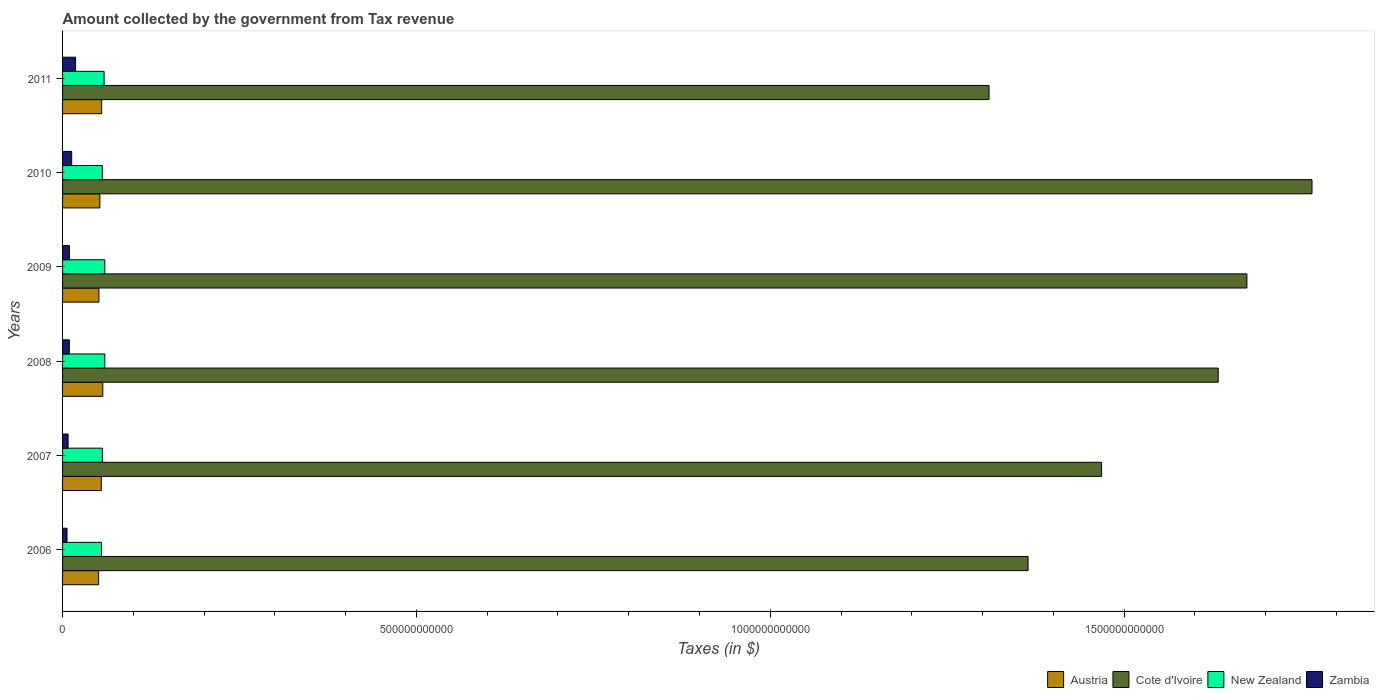How many different coloured bars are there?
Give a very brief answer. 4. Are the number of bars on each tick of the Y-axis equal?
Give a very brief answer. Yes. How many bars are there on the 3rd tick from the bottom?
Offer a very short reply. 4. In how many cases, is the number of bars for a given year not equal to the number of legend labels?
Provide a succinct answer. 0. What is the amount collected by the government from tax revenue in Cote d'Ivoire in 2009?
Your answer should be very brief. 1.67e+12. Across all years, what is the maximum amount collected by the government from tax revenue in Zambia?
Offer a terse response. 1.84e+1. Across all years, what is the minimum amount collected by the government from tax revenue in Cote d'Ivoire?
Offer a terse response. 1.31e+12. What is the total amount collected by the government from tax revenue in Zambia in the graph?
Provide a short and direct response. 6.46e+1. What is the difference between the amount collected by the government from tax revenue in Cote d'Ivoire in 2009 and that in 2010?
Keep it short and to the point. -9.20e+1. What is the difference between the amount collected by the government from tax revenue in Zambia in 2010 and the amount collected by the government from tax revenue in New Zealand in 2009?
Keep it short and to the point. -4.68e+1. What is the average amount collected by the government from tax revenue in Cote d'Ivoire per year?
Your response must be concise. 1.54e+12. In the year 2008, what is the difference between the amount collected by the government from tax revenue in Cote d'Ivoire and amount collected by the government from tax revenue in Zambia?
Ensure brevity in your answer.  1.62e+12. In how many years, is the amount collected by the government from tax revenue in Cote d'Ivoire greater than 100000000000 $?
Provide a short and direct response. 6. What is the ratio of the amount collected by the government from tax revenue in Cote d'Ivoire in 2010 to that in 2011?
Your answer should be compact. 1.35. What is the difference between the highest and the second highest amount collected by the government from tax revenue in New Zealand?
Offer a terse response. 6.41e+07. What is the difference between the highest and the lowest amount collected by the government from tax revenue in New Zealand?
Your answer should be compact. 4.69e+09. In how many years, is the amount collected by the government from tax revenue in Cote d'Ivoire greater than the average amount collected by the government from tax revenue in Cote d'Ivoire taken over all years?
Your answer should be very brief. 3. What does the 2nd bar from the top in 2006 represents?
Your answer should be very brief. New Zealand. What does the 4th bar from the bottom in 2011 represents?
Ensure brevity in your answer.  Zambia. Is it the case that in every year, the sum of the amount collected by the government from tax revenue in Cote d'Ivoire and amount collected by the government from tax revenue in New Zealand is greater than the amount collected by the government from tax revenue in Zambia?
Give a very brief answer. Yes. How many bars are there?
Provide a succinct answer. 24. Are all the bars in the graph horizontal?
Offer a very short reply. Yes. How many years are there in the graph?
Give a very brief answer. 6. What is the difference between two consecutive major ticks on the X-axis?
Make the answer very short. 5.00e+11. How are the legend labels stacked?
Your answer should be compact. Horizontal. What is the title of the graph?
Provide a succinct answer. Amount collected by the government from Tax revenue. What is the label or title of the X-axis?
Make the answer very short. Taxes (in $). What is the label or title of the Y-axis?
Your answer should be compact. Years. What is the Taxes (in $) of Austria in 2006?
Provide a succinct answer. 5.10e+1. What is the Taxes (in $) of Cote d'Ivoire in 2006?
Provide a short and direct response. 1.36e+12. What is the Taxes (in $) in New Zealand in 2006?
Provide a succinct answer. 5.50e+1. What is the Taxes (in $) in Zambia in 2006?
Make the answer very short. 6.30e+09. What is the Taxes (in $) of Austria in 2007?
Make the answer very short. 5.47e+1. What is the Taxes (in $) of Cote d'Ivoire in 2007?
Offer a terse response. 1.47e+12. What is the Taxes (in $) in New Zealand in 2007?
Give a very brief answer. 5.62e+1. What is the Taxes (in $) of Zambia in 2007?
Provide a succinct answer. 7.80e+09. What is the Taxes (in $) in Austria in 2008?
Your answer should be very brief. 5.69e+1. What is the Taxes (in $) in Cote d'Ivoire in 2008?
Ensure brevity in your answer.  1.63e+12. What is the Taxes (in $) in New Zealand in 2008?
Make the answer very short. 5.97e+1. What is the Taxes (in $) of Zambia in 2008?
Provide a succinct answer. 9.54e+09. What is the Taxes (in $) of Austria in 2009?
Keep it short and to the point. 5.14e+1. What is the Taxes (in $) in Cote d'Ivoire in 2009?
Give a very brief answer. 1.67e+12. What is the Taxes (in $) of New Zealand in 2009?
Offer a terse response. 5.96e+1. What is the Taxes (in $) in Zambia in 2009?
Your answer should be compact. 9.67e+09. What is the Taxes (in $) in Austria in 2010?
Provide a succinct answer. 5.27e+1. What is the Taxes (in $) of Cote d'Ivoire in 2010?
Your answer should be very brief. 1.77e+12. What is the Taxes (in $) in New Zealand in 2010?
Your response must be concise. 5.61e+1. What is the Taxes (in $) in Zambia in 2010?
Your response must be concise. 1.29e+1. What is the Taxes (in $) of Austria in 2011?
Your response must be concise. 5.52e+1. What is the Taxes (in $) of Cote d'Ivoire in 2011?
Provide a succinct answer. 1.31e+12. What is the Taxes (in $) of New Zealand in 2011?
Your answer should be very brief. 5.87e+1. What is the Taxes (in $) in Zambia in 2011?
Ensure brevity in your answer.  1.84e+1. Across all years, what is the maximum Taxes (in $) in Austria?
Ensure brevity in your answer.  5.69e+1. Across all years, what is the maximum Taxes (in $) in Cote d'Ivoire?
Provide a succinct answer. 1.77e+12. Across all years, what is the maximum Taxes (in $) of New Zealand?
Provide a succinct answer. 5.97e+1. Across all years, what is the maximum Taxes (in $) in Zambia?
Provide a succinct answer. 1.84e+1. Across all years, what is the minimum Taxes (in $) in Austria?
Keep it short and to the point. 5.10e+1. Across all years, what is the minimum Taxes (in $) of Cote d'Ivoire?
Ensure brevity in your answer.  1.31e+12. Across all years, what is the minimum Taxes (in $) in New Zealand?
Your answer should be very brief. 5.50e+1. Across all years, what is the minimum Taxes (in $) in Zambia?
Keep it short and to the point. 6.30e+09. What is the total Taxes (in $) in Austria in the graph?
Give a very brief answer. 3.22e+11. What is the total Taxes (in $) of Cote d'Ivoire in the graph?
Keep it short and to the point. 9.21e+12. What is the total Taxes (in $) of New Zealand in the graph?
Offer a terse response. 3.45e+11. What is the total Taxes (in $) of Zambia in the graph?
Give a very brief answer. 6.46e+1. What is the difference between the Taxes (in $) in Austria in 2006 and that in 2007?
Offer a very short reply. -3.76e+09. What is the difference between the Taxes (in $) in Cote d'Ivoire in 2006 and that in 2007?
Provide a succinct answer. -1.04e+11. What is the difference between the Taxes (in $) of New Zealand in 2006 and that in 2007?
Your answer should be very brief. -1.19e+09. What is the difference between the Taxes (in $) in Zambia in 2006 and that in 2007?
Provide a succinct answer. -1.50e+09. What is the difference between the Taxes (in $) in Austria in 2006 and that in 2008?
Provide a succinct answer. -5.88e+09. What is the difference between the Taxes (in $) of Cote d'Ivoire in 2006 and that in 2008?
Your response must be concise. -2.69e+11. What is the difference between the Taxes (in $) of New Zealand in 2006 and that in 2008?
Offer a very short reply. -4.69e+09. What is the difference between the Taxes (in $) in Zambia in 2006 and that in 2008?
Provide a succinct answer. -3.24e+09. What is the difference between the Taxes (in $) of Austria in 2006 and that in 2009?
Keep it short and to the point. -3.78e+08. What is the difference between the Taxes (in $) of Cote d'Ivoire in 2006 and that in 2009?
Your answer should be compact. -3.09e+11. What is the difference between the Taxes (in $) in New Zealand in 2006 and that in 2009?
Your answer should be compact. -4.63e+09. What is the difference between the Taxes (in $) in Zambia in 2006 and that in 2009?
Your answer should be very brief. -3.37e+09. What is the difference between the Taxes (in $) in Austria in 2006 and that in 2010?
Give a very brief answer. -1.77e+09. What is the difference between the Taxes (in $) of Cote d'Ivoire in 2006 and that in 2010?
Offer a very short reply. -4.01e+11. What is the difference between the Taxes (in $) of New Zealand in 2006 and that in 2010?
Offer a very short reply. -1.13e+09. What is the difference between the Taxes (in $) of Zambia in 2006 and that in 2010?
Offer a terse response. -6.58e+09. What is the difference between the Taxes (in $) of Austria in 2006 and that in 2011?
Your answer should be compact. -4.25e+09. What is the difference between the Taxes (in $) in Cote d'Ivoire in 2006 and that in 2011?
Make the answer very short. 5.51e+1. What is the difference between the Taxes (in $) of New Zealand in 2006 and that in 2011?
Keep it short and to the point. -3.67e+09. What is the difference between the Taxes (in $) in Zambia in 2006 and that in 2011?
Your response must be concise. -1.21e+1. What is the difference between the Taxes (in $) of Austria in 2007 and that in 2008?
Make the answer very short. -2.12e+09. What is the difference between the Taxes (in $) of Cote d'Ivoire in 2007 and that in 2008?
Ensure brevity in your answer.  -1.65e+11. What is the difference between the Taxes (in $) of New Zealand in 2007 and that in 2008?
Your answer should be very brief. -3.50e+09. What is the difference between the Taxes (in $) of Zambia in 2007 and that in 2008?
Your response must be concise. -1.74e+09. What is the difference between the Taxes (in $) of Austria in 2007 and that in 2009?
Keep it short and to the point. 3.38e+09. What is the difference between the Taxes (in $) in Cote d'Ivoire in 2007 and that in 2009?
Your answer should be very brief. -2.05e+11. What is the difference between the Taxes (in $) of New Zealand in 2007 and that in 2009?
Make the answer very short. -3.44e+09. What is the difference between the Taxes (in $) of Zambia in 2007 and that in 2009?
Your answer should be compact. -1.87e+09. What is the difference between the Taxes (in $) in Austria in 2007 and that in 2010?
Give a very brief answer. 1.99e+09. What is the difference between the Taxes (in $) in Cote d'Ivoire in 2007 and that in 2010?
Provide a short and direct response. -2.97e+11. What is the difference between the Taxes (in $) of New Zealand in 2007 and that in 2010?
Offer a terse response. 5.94e+07. What is the difference between the Taxes (in $) of Zambia in 2007 and that in 2010?
Offer a terse response. -5.08e+09. What is the difference between the Taxes (in $) of Austria in 2007 and that in 2011?
Give a very brief answer. -4.92e+08. What is the difference between the Taxes (in $) of Cote d'Ivoire in 2007 and that in 2011?
Offer a very short reply. 1.59e+11. What is the difference between the Taxes (in $) of New Zealand in 2007 and that in 2011?
Provide a short and direct response. -2.48e+09. What is the difference between the Taxes (in $) of Zambia in 2007 and that in 2011?
Offer a very short reply. -1.06e+1. What is the difference between the Taxes (in $) in Austria in 2008 and that in 2009?
Offer a terse response. 5.50e+09. What is the difference between the Taxes (in $) of Cote d'Ivoire in 2008 and that in 2009?
Keep it short and to the point. -4.06e+1. What is the difference between the Taxes (in $) of New Zealand in 2008 and that in 2009?
Give a very brief answer. 6.41e+07. What is the difference between the Taxes (in $) of Zambia in 2008 and that in 2009?
Your answer should be compact. -1.29e+08. What is the difference between the Taxes (in $) of Austria in 2008 and that in 2010?
Your response must be concise. 4.11e+09. What is the difference between the Taxes (in $) of Cote d'Ivoire in 2008 and that in 2010?
Offer a terse response. -1.33e+11. What is the difference between the Taxes (in $) of New Zealand in 2008 and that in 2010?
Keep it short and to the point. 3.56e+09. What is the difference between the Taxes (in $) in Zambia in 2008 and that in 2010?
Your answer should be compact. -3.34e+09. What is the difference between the Taxes (in $) in Austria in 2008 and that in 2011?
Your response must be concise. 1.62e+09. What is the difference between the Taxes (in $) in Cote d'Ivoire in 2008 and that in 2011?
Your response must be concise. 3.24e+11. What is the difference between the Taxes (in $) in New Zealand in 2008 and that in 2011?
Offer a terse response. 1.03e+09. What is the difference between the Taxes (in $) of Zambia in 2008 and that in 2011?
Your answer should be compact. -8.87e+09. What is the difference between the Taxes (in $) in Austria in 2009 and that in 2010?
Provide a short and direct response. -1.39e+09. What is the difference between the Taxes (in $) in Cote d'Ivoire in 2009 and that in 2010?
Your response must be concise. -9.20e+1. What is the difference between the Taxes (in $) in New Zealand in 2009 and that in 2010?
Make the answer very short. 3.50e+09. What is the difference between the Taxes (in $) of Zambia in 2009 and that in 2010?
Your answer should be very brief. -3.21e+09. What is the difference between the Taxes (in $) in Austria in 2009 and that in 2011?
Offer a terse response. -3.88e+09. What is the difference between the Taxes (in $) in Cote d'Ivoire in 2009 and that in 2011?
Keep it short and to the point. 3.64e+11. What is the difference between the Taxes (in $) in New Zealand in 2009 and that in 2011?
Keep it short and to the point. 9.61e+08. What is the difference between the Taxes (in $) of Zambia in 2009 and that in 2011?
Your answer should be compact. -8.75e+09. What is the difference between the Taxes (in $) in Austria in 2010 and that in 2011?
Your answer should be compact. -2.49e+09. What is the difference between the Taxes (in $) of Cote d'Ivoire in 2010 and that in 2011?
Give a very brief answer. 4.56e+11. What is the difference between the Taxes (in $) of New Zealand in 2010 and that in 2011?
Make the answer very short. -2.54e+09. What is the difference between the Taxes (in $) of Zambia in 2010 and that in 2011?
Offer a terse response. -5.54e+09. What is the difference between the Taxes (in $) of Austria in 2006 and the Taxes (in $) of Cote d'Ivoire in 2007?
Provide a short and direct response. -1.42e+12. What is the difference between the Taxes (in $) of Austria in 2006 and the Taxes (in $) of New Zealand in 2007?
Offer a terse response. -5.23e+09. What is the difference between the Taxes (in $) in Austria in 2006 and the Taxes (in $) in Zambia in 2007?
Keep it short and to the point. 4.32e+1. What is the difference between the Taxes (in $) of Cote d'Ivoire in 2006 and the Taxes (in $) of New Zealand in 2007?
Make the answer very short. 1.31e+12. What is the difference between the Taxes (in $) in Cote d'Ivoire in 2006 and the Taxes (in $) in Zambia in 2007?
Provide a succinct answer. 1.36e+12. What is the difference between the Taxes (in $) of New Zealand in 2006 and the Taxes (in $) of Zambia in 2007?
Provide a short and direct response. 4.72e+1. What is the difference between the Taxes (in $) in Austria in 2006 and the Taxes (in $) in Cote d'Ivoire in 2008?
Make the answer very short. -1.58e+12. What is the difference between the Taxes (in $) of Austria in 2006 and the Taxes (in $) of New Zealand in 2008?
Offer a very short reply. -8.73e+09. What is the difference between the Taxes (in $) in Austria in 2006 and the Taxes (in $) in Zambia in 2008?
Your answer should be very brief. 4.14e+1. What is the difference between the Taxes (in $) of Cote d'Ivoire in 2006 and the Taxes (in $) of New Zealand in 2008?
Your answer should be very brief. 1.30e+12. What is the difference between the Taxes (in $) in Cote d'Ivoire in 2006 and the Taxes (in $) in Zambia in 2008?
Provide a short and direct response. 1.35e+12. What is the difference between the Taxes (in $) of New Zealand in 2006 and the Taxes (in $) of Zambia in 2008?
Offer a very short reply. 4.55e+1. What is the difference between the Taxes (in $) in Austria in 2006 and the Taxes (in $) in Cote d'Ivoire in 2009?
Your answer should be compact. -1.62e+12. What is the difference between the Taxes (in $) of Austria in 2006 and the Taxes (in $) of New Zealand in 2009?
Make the answer very short. -8.67e+09. What is the difference between the Taxes (in $) in Austria in 2006 and the Taxes (in $) in Zambia in 2009?
Your response must be concise. 4.13e+1. What is the difference between the Taxes (in $) in Cote d'Ivoire in 2006 and the Taxes (in $) in New Zealand in 2009?
Offer a very short reply. 1.30e+12. What is the difference between the Taxes (in $) in Cote d'Ivoire in 2006 and the Taxes (in $) in Zambia in 2009?
Your answer should be very brief. 1.35e+12. What is the difference between the Taxes (in $) in New Zealand in 2006 and the Taxes (in $) in Zambia in 2009?
Offer a very short reply. 4.53e+1. What is the difference between the Taxes (in $) of Austria in 2006 and the Taxes (in $) of Cote d'Ivoire in 2010?
Provide a succinct answer. -1.71e+12. What is the difference between the Taxes (in $) in Austria in 2006 and the Taxes (in $) in New Zealand in 2010?
Your answer should be very brief. -5.17e+09. What is the difference between the Taxes (in $) of Austria in 2006 and the Taxes (in $) of Zambia in 2010?
Keep it short and to the point. 3.81e+1. What is the difference between the Taxes (in $) of Cote d'Ivoire in 2006 and the Taxes (in $) of New Zealand in 2010?
Your answer should be very brief. 1.31e+12. What is the difference between the Taxes (in $) of Cote d'Ivoire in 2006 and the Taxes (in $) of Zambia in 2010?
Offer a very short reply. 1.35e+12. What is the difference between the Taxes (in $) in New Zealand in 2006 and the Taxes (in $) in Zambia in 2010?
Ensure brevity in your answer.  4.21e+1. What is the difference between the Taxes (in $) of Austria in 2006 and the Taxes (in $) of Cote d'Ivoire in 2011?
Provide a short and direct response. -1.26e+12. What is the difference between the Taxes (in $) of Austria in 2006 and the Taxes (in $) of New Zealand in 2011?
Your response must be concise. -7.71e+09. What is the difference between the Taxes (in $) in Austria in 2006 and the Taxes (in $) in Zambia in 2011?
Offer a terse response. 3.26e+1. What is the difference between the Taxes (in $) in Cote d'Ivoire in 2006 and the Taxes (in $) in New Zealand in 2011?
Give a very brief answer. 1.31e+12. What is the difference between the Taxes (in $) in Cote d'Ivoire in 2006 and the Taxes (in $) in Zambia in 2011?
Offer a terse response. 1.35e+12. What is the difference between the Taxes (in $) of New Zealand in 2006 and the Taxes (in $) of Zambia in 2011?
Your response must be concise. 3.66e+1. What is the difference between the Taxes (in $) of Austria in 2007 and the Taxes (in $) of Cote d'Ivoire in 2008?
Give a very brief answer. -1.58e+12. What is the difference between the Taxes (in $) in Austria in 2007 and the Taxes (in $) in New Zealand in 2008?
Ensure brevity in your answer.  -4.97e+09. What is the difference between the Taxes (in $) of Austria in 2007 and the Taxes (in $) of Zambia in 2008?
Your answer should be compact. 4.52e+1. What is the difference between the Taxes (in $) of Cote d'Ivoire in 2007 and the Taxes (in $) of New Zealand in 2008?
Provide a succinct answer. 1.41e+12. What is the difference between the Taxes (in $) in Cote d'Ivoire in 2007 and the Taxes (in $) in Zambia in 2008?
Ensure brevity in your answer.  1.46e+12. What is the difference between the Taxes (in $) in New Zealand in 2007 and the Taxes (in $) in Zambia in 2008?
Give a very brief answer. 4.67e+1. What is the difference between the Taxes (in $) of Austria in 2007 and the Taxes (in $) of Cote d'Ivoire in 2009?
Give a very brief answer. -1.62e+12. What is the difference between the Taxes (in $) in Austria in 2007 and the Taxes (in $) in New Zealand in 2009?
Ensure brevity in your answer.  -4.91e+09. What is the difference between the Taxes (in $) of Austria in 2007 and the Taxes (in $) of Zambia in 2009?
Offer a very short reply. 4.51e+1. What is the difference between the Taxes (in $) of Cote d'Ivoire in 2007 and the Taxes (in $) of New Zealand in 2009?
Your answer should be very brief. 1.41e+12. What is the difference between the Taxes (in $) in Cote d'Ivoire in 2007 and the Taxes (in $) in Zambia in 2009?
Ensure brevity in your answer.  1.46e+12. What is the difference between the Taxes (in $) in New Zealand in 2007 and the Taxes (in $) in Zambia in 2009?
Ensure brevity in your answer.  4.65e+1. What is the difference between the Taxes (in $) in Austria in 2007 and the Taxes (in $) in Cote d'Ivoire in 2010?
Offer a terse response. -1.71e+12. What is the difference between the Taxes (in $) in Austria in 2007 and the Taxes (in $) in New Zealand in 2010?
Provide a succinct answer. -1.41e+09. What is the difference between the Taxes (in $) of Austria in 2007 and the Taxes (in $) of Zambia in 2010?
Keep it short and to the point. 4.19e+1. What is the difference between the Taxes (in $) of Cote d'Ivoire in 2007 and the Taxes (in $) of New Zealand in 2010?
Provide a short and direct response. 1.41e+12. What is the difference between the Taxes (in $) in Cote d'Ivoire in 2007 and the Taxes (in $) in Zambia in 2010?
Offer a terse response. 1.46e+12. What is the difference between the Taxes (in $) of New Zealand in 2007 and the Taxes (in $) of Zambia in 2010?
Offer a very short reply. 4.33e+1. What is the difference between the Taxes (in $) of Austria in 2007 and the Taxes (in $) of Cote d'Ivoire in 2011?
Provide a succinct answer. -1.25e+12. What is the difference between the Taxes (in $) in Austria in 2007 and the Taxes (in $) in New Zealand in 2011?
Offer a terse response. -3.95e+09. What is the difference between the Taxes (in $) in Austria in 2007 and the Taxes (in $) in Zambia in 2011?
Ensure brevity in your answer.  3.63e+1. What is the difference between the Taxes (in $) in Cote d'Ivoire in 2007 and the Taxes (in $) in New Zealand in 2011?
Offer a terse response. 1.41e+12. What is the difference between the Taxes (in $) in Cote d'Ivoire in 2007 and the Taxes (in $) in Zambia in 2011?
Ensure brevity in your answer.  1.45e+12. What is the difference between the Taxes (in $) of New Zealand in 2007 and the Taxes (in $) of Zambia in 2011?
Offer a very short reply. 3.78e+1. What is the difference between the Taxes (in $) of Austria in 2008 and the Taxes (in $) of Cote d'Ivoire in 2009?
Make the answer very short. -1.62e+12. What is the difference between the Taxes (in $) in Austria in 2008 and the Taxes (in $) in New Zealand in 2009?
Your response must be concise. -2.79e+09. What is the difference between the Taxes (in $) in Austria in 2008 and the Taxes (in $) in Zambia in 2009?
Your answer should be compact. 4.72e+1. What is the difference between the Taxes (in $) in Cote d'Ivoire in 2008 and the Taxes (in $) in New Zealand in 2009?
Offer a terse response. 1.57e+12. What is the difference between the Taxes (in $) of Cote d'Ivoire in 2008 and the Taxes (in $) of Zambia in 2009?
Ensure brevity in your answer.  1.62e+12. What is the difference between the Taxes (in $) in New Zealand in 2008 and the Taxes (in $) in Zambia in 2009?
Provide a short and direct response. 5.00e+1. What is the difference between the Taxes (in $) of Austria in 2008 and the Taxes (in $) of Cote d'Ivoire in 2010?
Give a very brief answer. -1.71e+12. What is the difference between the Taxes (in $) in Austria in 2008 and the Taxes (in $) in New Zealand in 2010?
Provide a succinct answer. 7.08e+08. What is the difference between the Taxes (in $) in Austria in 2008 and the Taxes (in $) in Zambia in 2010?
Keep it short and to the point. 4.40e+1. What is the difference between the Taxes (in $) in Cote d'Ivoire in 2008 and the Taxes (in $) in New Zealand in 2010?
Your answer should be compact. 1.58e+12. What is the difference between the Taxes (in $) in Cote d'Ivoire in 2008 and the Taxes (in $) in Zambia in 2010?
Your answer should be compact. 1.62e+12. What is the difference between the Taxes (in $) in New Zealand in 2008 and the Taxes (in $) in Zambia in 2010?
Make the answer very short. 4.68e+1. What is the difference between the Taxes (in $) of Austria in 2008 and the Taxes (in $) of Cote d'Ivoire in 2011?
Provide a succinct answer. -1.25e+12. What is the difference between the Taxes (in $) in Austria in 2008 and the Taxes (in $) in New Zealand in 2011?
Make the answer very short. -1.83e+09. What is the difference between the Taxes (in $) of Austria in 2008 and the Taxes (in $) of Zambia in 2011?
Keep it short and to the point. 3.84e+1. What is the difference between the Taxes (in $) of Cote d'Ivoire in 2008 and the Taxes (in $) of New Zealand in 2011?
Your response must be concise. 1.57e+12. What is the difference between the Taxes (in $) in Cote d'Ivoire in 2008 and the Taxes (in $) in Zambia in 2011?
Give a very brief answer. 1.61e+12. What is the difference between the Taxes (in $) of New Zealand in 2008 and the Taxes (in $) of Zambia in 2011?
Your answer should be compact. 4.13e+1. What is the difference between the Taxes (in $) in Austria in 2009 and the Taxes (in $) in Cote d'Ivoire in 2010?
Your answer should be compact. -1.71e+12. What is the difference between the Taxes (in $) in Austria in 2009 and the Taxes (in $) in New Zealand in 2010?
Your answer should be very brief. -4.79e+09. What is the difference between the Taxes (in $) of Austria in 2009 and the Taxes (in $) of Zambia in 2010?
Make the answer very short. 3.85e+1. What is the difference between the Taxes (in $) of Cote d'Ivoire in 2009 and the Taxes (in $) of New Zealand in 2010?
Give a very brief answer. 1.62e+12. What is the difference between the Taxes (in $) in Cote d'Ivoire in 2009 and the Taxes (in $) in Zambia in 2010?
Offer a very short reply. 1.66e+12. What is the difference between the Taxes (in $) of New Zealand in 2009 and the Taxes (in $) of Zambia in 2010?
Your response must be concise. 4.68e+1. What is the difference between the Taxes (in $) of Austria in 2009 and the Taxes (in $) of Cote d'Ivoire in 2011?
Ensure brevity in your answer.  -1.26e+12. What is the difference between the Taxes (in $) of Austria in 2009 and the Taxes (in $) of New Zealand in 2011?
Make the answer very short. -7.33e+09. What is the difference between the Taxes (in $) of Austria in 2009 and the Taxes (in $) of Zambia in 2011?
Keep it short and to the point. 3.29e+1. What is the difference between the Taxes (in $) of Cote d'Ivoire in 2009 and the Taxes (in $) of New Zealand in 2011?
Ensure brevity in your answer.  1.61e+12. What is the difference between the Taxes (in $) in Cote d'Ivoire in 2009 and the Taxes (in $) in Zambia in 2011?
Give a very brief answer. 1.66e+12. What is the difference between the Taxes (in $) of New Zealand in 2009 and the Taxes (in $) of Zambia in 2011?
Offer a very short reply. 4.12e+1. What is the difference between the Taxes (in $) of Austria in 2010 and the Taxes (in $) of Cote d'Ivoire in 2011?
Keep it short and to the point. -1.26e+12. What is the difference between the Taxes (in $) of Austria in 2010 and the Taxes (in $) of New Zealand in 2011?
Provide a short and direct response. -5.94e+09. What is the difference between the Taxes (in $) in Austria in 2010 and the Taxes (in $) in Zambia in 2011?
Offer a very short reply. 3.43e+1. What is the difference between the Taxes (in $) in Cote d'Ivoire in 2010 and the Taxes (in $) in New Zealand in 2011?
Keep it short and to the point. 1.71e+12. What is the difference between the Taxes (in $) in Cote d'Ivoire in 2010 and the Taxes (in $) in Zambia in 2011?
Offer a very short reply. 1.75e+12. What is the difference between the Taxes (in $) in New Zealand in 2010 and the Taxes (in $) in Zambia in 2011?
Provide a succinct answer. 3.77e+1. What is the average Taxes (in $) of Austria per year?
Give a very brief answer. 5.37e+1. What is the average Taxes (in $) of Cote d'Ivoire per year?
Provide a short and direct response. 1.54e+12. What is the average Taxes (in $) in New Zealand per year?
Your answer should be very brief. 5.76e+1. What is the average Taxes (in $) in Zambia per year?
Your answer should be compact. 1.08e+1. In the year 2006, what is the difference between the Taxes (in $) of Austria and Taxes (in $) of Cote d'Ivoire?
Your answer should be very brief. -1.31e+12. In the year 2006, what is the difference between the Taxes (in $) in Austria and Taxes (in $) in New Zealand?
Provide a short and direct response. -4.04e+09. In the year 2006, what is the difference between the Taxes (in $) of Austria and Taxes (in $) of Zambia?
Your answer should be very brief. 4.47e+1. In the year 2006, what is the difference between the Taxes (in $) of Cote d'Ivoire and Taxes (in $) of New Zealand?
Provide a short and direct response. 1.31e+12. In the year 2006, what is the difference between the Taxes (in $) in Cote d'Ivoire and Taxes (in $) in Zambia?
Your answer should be very brief. 1.36e+12. In the year 2006, what is the difference between the Taxes (in $) in New Zealand and Taxes (in $) in Zambia?
Ensure brevity in your answer.  4.87e+1. In the year 2007, what is the difference between the Taxes (in $) in Austria and Taxes (in $) in Cote d'Ivoire?
Offer a terse response. -1.41e+12. In the year 2007, what is the difference between the Taxes (in $) of Austria and Taxes (in $) of New Zealand?
Provide a succinct answer. -1.47e+09. In the year 2007, what is the difference between the Taxes (in $) of Austria and Taxes (in $) of Zambia?
Your answer should be compact. 4.69e+1. In the year 2007, what is the difference between the Taxes (in $) in Cote d'Ivoire and Taxes (in $) in New Zealand?
Your response must be concise. 1.41e+12. In the year 2007, what is the difference between the Taxes (in $) in Cote d'Ivoire and Taxes (in $) in Zambia?
Make the answer very short. 1.46e+12. In the year 2007, what is the difference between the Taxes (in $) of New Zealand and Taxes (in $) of Zambia?
Ensure brevity in your answer.  4.84e+1. In the year 2008, what is the difference between the Taxes (in $) in Austria and Taxes (in $) in Cote d'Ivoire?
Offer a terse response. -1.58e+12. In the year 2008, what is the difference between the Taxes (in $) of Austria and Taxes (in $) of New Zealand?
Give a very brief answer. -2.86e+09. In the year 2008, what is the difference between the Taxes (in $) in Austria and Taxes (in $) in Zambia?
Keep it short and to the point. 4.73e+1. In the year 2008, what is the difference between the Taxes (in $) of Cote d'Ivoire and Taxes (in $) of New Zealand?
Provide a succinct answer. 1.57e+12. In the year 2008, what is the difference between the Taxes (in $) of Cote d'Ivoire and Taxes (in $) of Zambia?
Your answer should be compact. 1.62e+12. In the year 2008, what is the difference between the Taxes (in $) of New Zealand and Taxes (in $) of Zambia?
Keep it short and to the point. 5.02e+1. In the year 2009, what is the difference between the Taxes (in $) of Austria and Taxes (in $) of Cote d'Ivoire?
Give a very brief answer. -1.62e+12. In the year 2009, what is the difference between the Taxes (in $) in Austria and Taxes (in $) in New Zealand?
Keep it short and to the point. -8.29e+09. In the year 2009, what is the difference between the Taxes (in $) of Austria and Taxes (in $) of Zambia?
Your answer should be compact. 4.17e+1. In the year 2009, what is the difference between the Taxes (in $) in Cote d'Ivoire and Taxes (in $) in New Zealand?
Your answer should be very brief. 1.61e+12. In the year 2009, what is the difference between the Taxes (in $) in Cote d'Ivoire and Taxes (in $) in Zambia?
Your answer should be compact. 1.66e+12. In the year 2009, what is the difference between the Taxes (in $) in New Zealand and Taxes (in $) in Zambia?
Offer a very short reply. 5.00e+1. In the year 2010, what is the difference between the Taxes (in $) of Austria and Taxes (in $) of Cote d'Ivoire?
Your answer should be very brief. -1.71e+12. In the year 2010, what is the difference between the Taxes (in $) of Austria and Taxes (in $) of New Zealand?
Give a very brief answer. -3.40e+09. In the year 2010, what is the difference between the Taxes (in $) in Austria and Taxes (in $) in Zambia?
Ensure brevity in your answer.  3.99e+1. In the year 2010, what is the difference between the Taxes (in $) in Cote d'Ivoire and Taxes (in $) in New Zealand?
Your answer should be very brief. 1.71e+12. In the year 2010, what is the difference between the Taxes (in $) in Cote d'Ivoire and Taxes (in $) in Zambia?
Your answer should be very brief. 1.75e+12. In the year 2010, what is the difference between the Taxes (in $) in New Zealand and Taxes (in $) in Zambia?
Your response must be concise. 4.33e+1. In the year 2011, what is the difference between the Taxes (in $) of Austria and Taxes (in $) of Cote d'Ivoire?
Offer a very short reply. -1.25e+12. In the year 2011, what is the difference between the Taxes (in $) in Austria and Taxes (in $) in New Zealand?
Give a very brief answer. -3.45e+09. In the year 2011, what is the difference between the Taxes (in $) of Austria and Taxes (in $) of Zambia?
Ensure brevity in your answer.  3.68e+1. In the year 2011, what is the difference between the Taxes (in $) of Cote d'Ivoire and Taxes (in $) of New Zealand?
Your response must be concise. 1.25e+12. In the year 2011, what is the difference between the Taxes (in $) of Cote d'Ivoire and Taxes (in $) of Zambia?
Offer a very short reply. 1.29e+12. In the year 2011, what is the difference between the Taxes (in $) of New Zealand and Taxes (in $) of Zambia?
Your answer should be compact. 4.03e+1. What is the ratio of the Taxes (in $) in Austria in 2006 to that in 2007?
Your answer should be very brief. 0.93. What is the ratio of the Taxes (in $) in Cote d'Ivoire in 2006 to that in 2007?
Provide a short and direct response. 0.93. What is the ratio of the Taxes (in $) in New Zealand in 2006 to that in 2007?
Provide a succinct answer. 0.98. What is the ratio of the Taxes (in $) in Zambia in 2006 to that in 2007?
Give a very brief answer. 0.81. What is the ratio of the Taxes (in $) in Austria in 2006 to that in 2008?
Your response must be concise. 0.9. What is the ratio of the Taxes (in $) of Cote d'Ivoire in 2006 to that in 2008?
Keep it short and to the point. 0.84. What is the ratio of the Taxes (in $) in New Zealand in 2006 to that in 2008?
Make the answer very short. 0.92. What is the ratio of the Taxes (in $) of Zambia in 2006 to that in 2008?
Your answer should be compact. 0.66. What is the ratio of the Taxes (in $) in Cote d'Ivoire in 2006 to that in 2009?
Offer a very short reply. 0.82. What is the ratio of the Taxes (in $) in New Zealand in 2006 to that in 2009?
Your response must be concise. 0.92. What is the ratio of the Taxes (in $) of Zambia in 2006 to that in 2009?
Provide a short and direct response. 0.65. What is the ratio of the Taxes (in $) in Austria in 2006 to that in 2010?
Keep it short and to the point. 0.97. What is the ratio of the Taxes (in $) of Cote d'Ivoire in 2006 to that in 2010?
Give a very brief answer. 0.77. What is the ratio of the Taxes (in $) of New Zealand in 2006 to that in 2010?
Offer a terse response. 0.98. What is the ratio of the Taxes (in $) in Zambia in 2006 to that in 2010?
Provide a succinct answer. 0.49. What is the ratio of the Taxes (in $) of Austria in 2006 to that in 2011?
Give a very brief answer. 0.92. What is the ratio of the Taxes (in $) in Cote d'Ivoire in 2006 to that in 2011?
Provide a succinct answer. 1.04. What is the ratio of the Taxes (in $) in New Zealand in 2006 to that in 2011?
Keep it short and to the point. 0.94. What is the ratio of the Taxes (in $) of Zambia in 2006 to that in 2011?
Provide a succinct answer. 0.34. What is the ratio of the Taxes (in $) of Austria in 2007 to that in 2008?
Give a very brief answer. 0.96. What is the ratio of the Taxes (in $) in Cote d'Ivoire in 2007 to that in 2008?
Offer a very short reply. 0.9. What is the ratio of the Taxes (in $) of New Zealand in 2007 to that in 2008?
Keep it short and to the point. 0.94. What is the ratio of the Taxes (in $) of Zambia in 2007 to that in 2008?
Offer a terse response. 0.82. What is the ratio of the Taxes (in $) of Austria in 2007 to that in 2009?
Make the answer very short. 1.07. What is the ratio of the Taxes (in $) of Cote d'Ivoire in 2007 to that in 2009?
Provide a short and direct response. 0.88. What is the ratio of the Taxes (in $) in New Zealand in 2007 to that in 2009?
Your answer should be very brief. 0.94. What is the ratio of the Taxes (in $) of Zambia in 2007 to that in 2009?
Provide a succinct answer. 0.81. What is the ratio of the Taxes (in $) of Austria in 2007 to that in 2010?
Your answer should be very brief. 1.04. What is the ratio of the Taxes (in $) in Cote d'Ivoire in 2007 to that in 2010?
Provide a short and direct response. 0.83. What is the ratio of the Taxes (in $) in Zambia in 2007 to that in 2010?
Your answer should be compact. 0.61. What is the ratio of the Taxes (in $) of Cote d'Ivoire in 2007 to that in 2011?
Your answer should be very brief. 1.12. What is the ratio of the Taxes (in $) in New Zealand in 2007 to that in 2011?
Ensure brevity in your answer.  0.96. What is the ratio of the Taxes (in $) of Zambia in 2007 to that in 2011?
Your answer should be compact. 0.42. What is the ratio of the Taxes (in $) of Austria in 2008 to that in 2009?
Offer a very short reply. 1.11. What is the ratio of the Taxes (in $) in Cote d'Ivoire in 2008 to that in 2009?
Offer a terse response. 0.98. What is the ratio of the Taxes (in $) of Zambia in 2008 to that in 2009?
Provide a succinct answer. 0.99. What is the ratio of the Taxes (in $) of Austria in 2008 to that in 2010?
Your response must be concise. 1.08. What is the ratio of the Taxes (in $) of Cote d'Ivoire in 2008 to that in 2010?
Make the answer very short. 0.92. What is the ratio of the Taxes (in $) of New Zealand in 2008 to that in 2010?
Provide a short and direct response. 1.06. What is the ratio of the Taxes (in $) in Zambia in 2008 to that in 2010?
Your answer should be compact. 0.74. What is the ratio of the Taxes (in $) of Austria in 2008 to that in 2011?
Keep it short and to the point. 1.03. What is the ratio of the Taxes (in $) of Cote d'Ivoire in 2008 to that in 2011?
Ensure brevity in your answer.  1.25. What is the ratio of the Taxes (in $) in New Zealand in 2008 to that in 2011?
Provide a short and direct response. 1.02. What is the ratio of the Taxes (in $) of Zambia in 2008 to that in 2011?
Give a very brief answer. 0.52. What is the ratio of the Taxes (in $) in Austria in 2009 to that in 2010?
Provide a short and direct response. 0.97. What is the ratio of the Taxes (in $) of Cote d'Ivoire in 2009 to that in 2010?
Ensure brevity in your answer.  0.95. What is the ratio of the Taxes (in $) of New Zealand in 2009 to that in 2010?
Offer a very short reply. 1.06. What is the ratio of the Taxes (in $) of Zambia in 2009 to that in 2010?
Offer a terse response. 0.75. What is the ratio of the Taxes (in $) of Austria in 2009 to that in 2011?
Ensure brevity in your answer.  0.93. What is the ratio of the Taxes (in $) in Cote d'Ivoire in 2009 to that in 2011?
Offer a terse response. 1.28. What is the ratio of the Taxes (in $) of New Zealand in 2009 to that in 2011?
Keep it short and to the point. 1.02. What is the ratio of the Taxes (in $) of Zambia in 2009 to that in 2011?
Your answer should be very brief. 0.53. What is the ratio of the Taxes (in $) in Austria in 2010 to that in 2011?
Keep it short and to the point. 0.95. What is the ratio of the Taxes (in $) in Cote d'Ivoire in 2010 to that in 2011?
Your answer should be compact. 1.35. What is the ratio of the Taxes (in $) in New Zealand in 2010 to that in 2011?
Your answer should be compact. 0.96. What is the ratio of the Taxes (in $) in Zambia in 2010 to that in 2011?
Give a very brief answer. 0.7. What is the difference between the highest and the second highest Taxes (in $) of Austria?
Your response must be concise. 1.62e+09. What is the difference between the highest and the second highest Taxes (in $) in Cote d'Ivoire?
Your response must be concise. 9.20e+1. What is the difference between the highest and the second highest Taxes (in $) of New Zealand?
Provide a short and direct response. 6.41e+07. What is the difference between the highest and the second highest Taxes (in $) in Zambia?
Provide a succinct answer. 5.54e+09. What is the difference between the highest and the lowest Taxes (in $) in Austria?
Provide a succinct answer. 5.88e+09. What is the difference between the highest and the lowest Taxes (in $) in Cote d'Ivoire?
Keep it short and to the point. 4.56e+11. What is the difference between the highest and the lowest Taxes (in $) of New Zealand?
Offer a terse response. 4.69e+09. What is the difference between the highest and the lowest Taxes (in $) of Zambia?
Your answer should be very brief. 1.21e+1. 